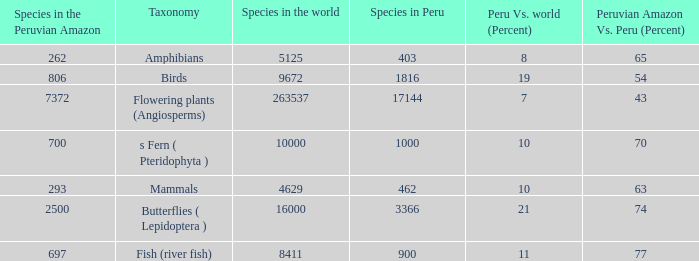What's the maximum peru vs. world (percent) with 9672 species in the world  19.0. 